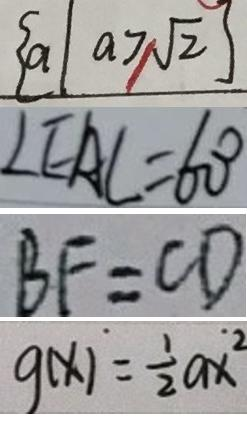<formula> <loc_0><loc_0><loc_500><loc_500>\{ a \vert a \geq \sqrt { 2 } \} 
 \angle E A C = 6 0 ^ { \circ } 
 B F = C D 
 g ( x ) = \frac { 1 } { 2 } a x ^ { 2 }</formula> 